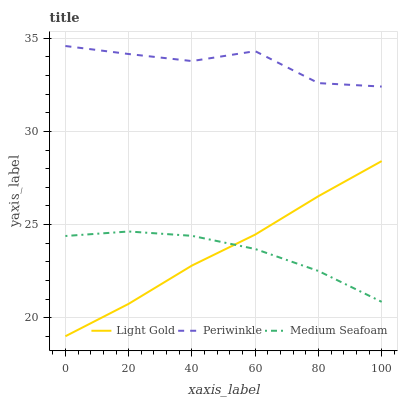Does Medium Seafoam have the minimum area under the curve?
Answer yes or no. Yes. Does Periwinkle have the maximum area under the curve?
Answer yes or no. Yes. Does Light Gold have the minimum area under the curve?
Answer yes or no. No. Does Light Gold have the maximum area under the curve?
Answer yes or no. No. Is Light Gold the smoothest?
Answer yes or no. Yes. Is Periwinkle the roughest?
Answer yes or no. Yes. Is Medium Seafoam the smoothest?
Answer yes or no. No. Is Medium Seafoam the roughest?
Answer yes or no. No. Does Light Gold have the lowest value?
Answer yes or no. Yes. Does Medium Seafoam have the lowest value?
Answer yes or no. No. Does Periwinkle have the highest value?
Answer yes or no. Yes. Does Light Gold have the highest value?
Answer yes or no. No. Is Light Gold less than Periwinkle?
Answer yes or no. Yes. Is Periwinkle greater than Medium Seafoam?
Answer yes or no. Yes. Does Medium Seafoam intersect Light Gold?
Answer yes or no. Yes. Is Medium Seafoam less than Light Gold?
Answer yes or no. No. Is Medium Seafoam greater than Light Gold?
Answer yes or no. No. Does Light Gold intersect Periwinkle?
Answer yes or no. No. 